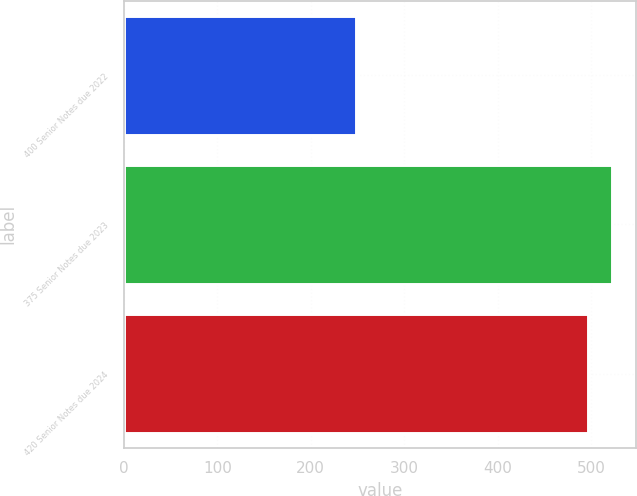<chart> <loc_0><loc_0><loc_500><loc_500><bar_chart><fcel>400 Senior Notes due 2022<fcel>375 Senior Notes due 2023<fcel>420 Senior Notes due 2024<nl><fcel>248.2<fcel>522.25<fcel>497.3<nl></chart> 